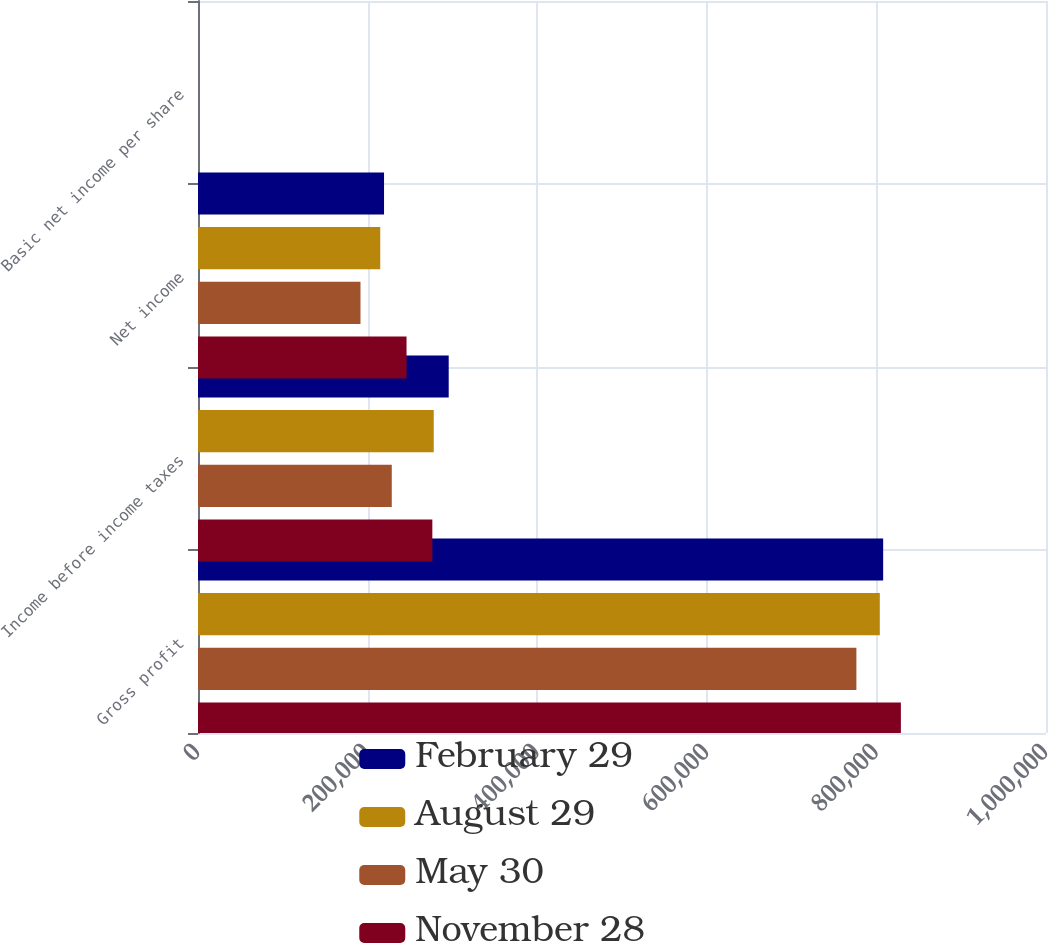Convert chart. <chart><loc_0><loc_0><loc_500><loc_500><stacked_bar_chart><ecel><fcel>Gross profit<fcel>Income before income taxes<fcel>Net income<fcel>Basic net income per share<nl><fcel>February 29<fcel>807970<fcel>295644<fcel>219379<fcel>0.39<nl><fcel>August 29<fcel>804020<fcel>278006<fcel>214910<fcel>0.4<nl><fcel>May 30<fcel>776406<fcel>228514<fcel>191608<fcel>0.36<nl><fcel>November 28<fcel>828863<fcel>276344<fcel>245917<fcel>0.47<nl></chart> 